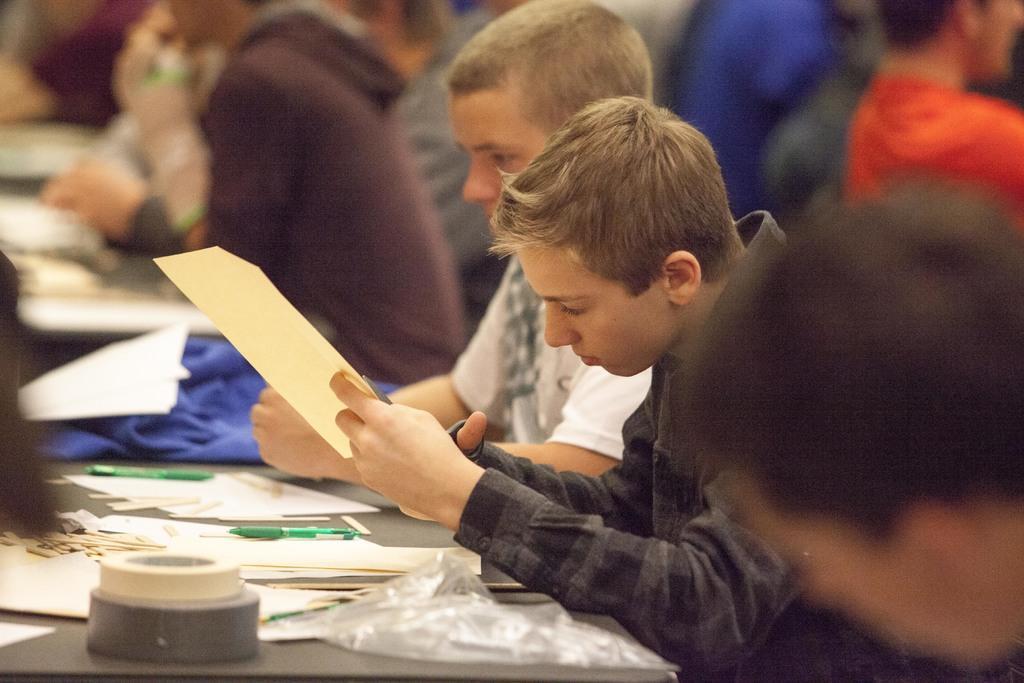In one or two sentences, can you explain what this image depicts? In this picture there is a boy who is holding a paper and scissor, beside him we can see another boy who is wearing white t-shirt. He is sitting near to the table. On the table we can see the papers, cloth, pen, tape, plastic covers and other objects. in the background we can see many peoples were sitting on the chair. 